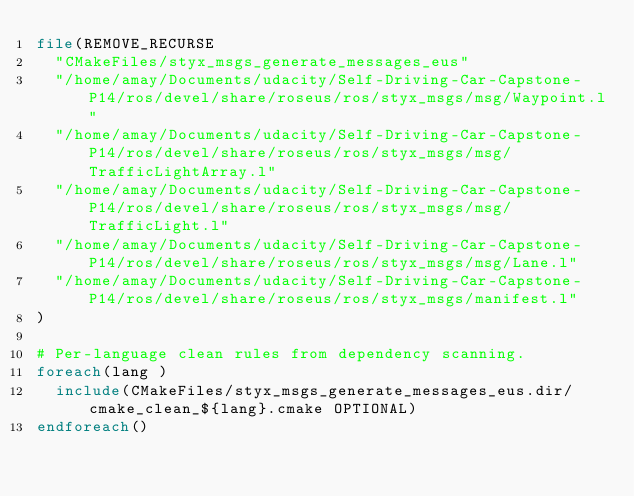<code> <loc_0><loc_0><loc_500><loc_500><_CMake_>file(REMOVE_RECURSE
  "CMakeFiles/styx_msgs_generate_messages_eus"
  "/home/amay/Documents/udacity/Self-Driving-Car-Capstone-P14/ros/devel/share/roseus/ros/styx_msgs/msg/Waypoint.l"
  "/home/amay/Documents/udacity/Self-Driving-Car-Capstone-P14/ros/devel/share/roseus/ros/styx_msgs/msg/TrafficLightArray.l"
  "/home/amay/Documents/udacity/Self-Driving-Car-Capstone-P14/ros/devel/share/roseus/ros/styx_msgs/msg/TrafficLight.l"
  "/home/amay/Documents/udacity/Self-Driving-Car-Capstone-P14/ros/devel/share/roseus/ros/styx_msgs/msg/Lane.l"
  "/home/amay/Documents/udacity/Self-Driving-Car-Capstone-P14/ros/devel/share/roseus/ros/styx_msgs/manifest.l"
)

# Per-language clean rules from dependency scanning.
foreach(lang )
  include(CMakeFiles/styx_msgs_generate_messages_eus.dir/cmake_clean_${lang}.cmake OPTIONAL)
endforeach()
</code> 